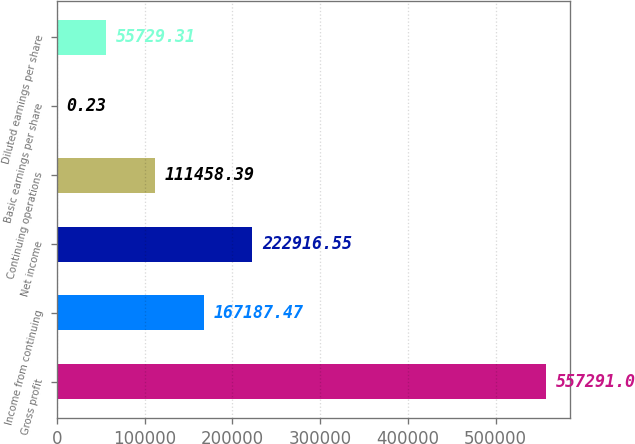<chart> <loc_0><loc_0><loc_500><loc_500><bar_chart><fcel>Gross profit<fcel>Income from continuing<fcel>Net income<fcel>Continuing operations<fcel>Basic earnings per share<fcel>Diluted earnings per share<nl><fcel>557291<fcel>167187<fcel>222917<fcel>111458<fcel>0.23<fcel>55729.3<nl></chart> 